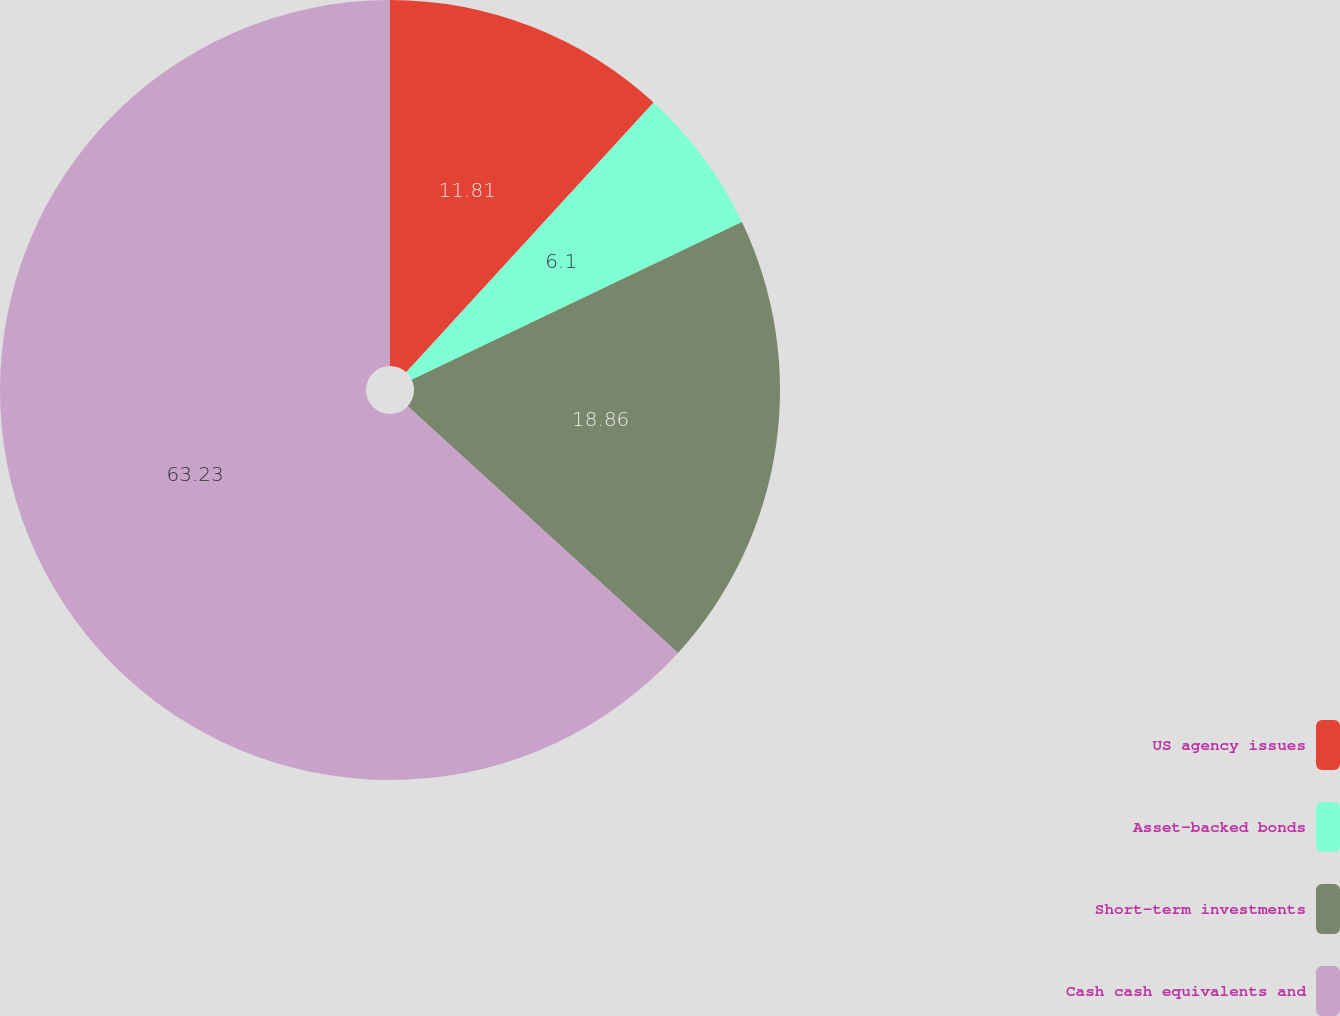Convert chart. <chart><loc_0><loc_0><loc_500><loc_500><pie_chart><fcel>US agency issues<fcel>Asset-backed bonds<fcel>Short-term investments<fcel>Cash cash equivalents and<nl><fcel>11.81%<fcel>6.1%<fcel>18.86%<fcel>63.22%<nl></chart> 